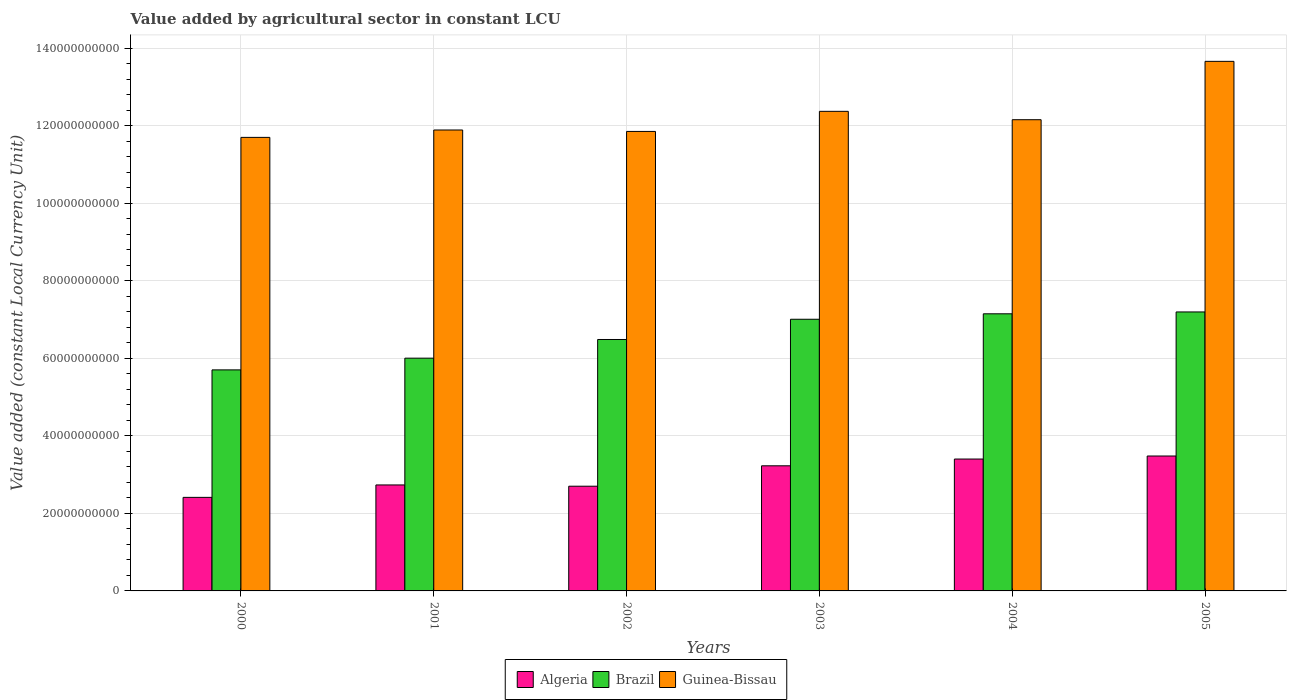How many different coloured bars are there?
Your answer should be compact. 3. How many groups of bars are there?
Keep it short and to the point. 6. How many bars are there on the 1st tick from the left?
Offer a terse response. 3. How many bars are there on the 5th tick from the right?
Provide a succinct answer. 3. What is the label of the 2nd group of bars from the left?
Give a very brief answer. 2001. What is the value added by agricultural sector in Algeria in 2004?
Offer a very short reply. 3.40e+1. Across all years, what is the maximum value added by agricultural sector in Algeria?
Give a very brief answer. 3.48e+1. Across all years, what is the minimum value added by agricultural sector in Brazil?
Provide a succinct answer. 5.70e+1. In which year was the value added by agricultural sector in Brazil maximum?
Your answer should be compact. 2005. In which year was the value added by agricultural sector in Algeria minimum?
Your answer should be compact. 2000. What is the total value added by agricultural sector in Guinea-Bissau in the graph?
Offer a very short reply. 7.36e+11. What is the difference between the value added by agricultural sector in Guinea-Bissau in 2003 and that in 2005?
Provide a succinct answer. -1.29e+1. What is the difference between the value added by agricultural sector in Brazil in 2000 and the value added by agricultural sector in Guinea-Bissau in 2005?
Offer a terse response. -7.96e+1. What is the average value added by agricultural sector in Guinea-Bissau per year?
Offer a very short reply. 1.23e+11. In the year 2002, what is the difference between the value added by agricultural sector in Guinea-Bissau and value added by agricultural sector in Brazil?
Your response must be concise. 5.37e+1. What is the ratio of the value added by agricultural sector in Algeria in 2000 to that in 2003?
Your answer should be compact. 0.75. Is the value added by agricultural sector in Guinea-Bissau in 2001 less than that in 2004?
Your answer should be compact. Yes. What is the difference between the highest and the second highest value added by agricultural sector in Guinea-Bissau?
Your response must be concise. 1.29e+1. What is the difference between the highest and the lowest value added by agricultural sector in Algeria?
Offer a very short reply. 1.07e+1. What does the 1st bar from the left in 2004 represents?
Give a very brief answer. Algeria. What does the 1st bar from the right in 2000 represents?
Ensure brevity in your answer.  Guinea-Bissau. How many bars are there?
Offer a very short reply. 18. Are all the bars in the graph horizontal?
Make the answer very short. No. How many years are there in the graph?
Make the answer very short. 6. Are the values on the major ticks of Y-axis written in scientific E-notation?
Offer a very short reply. No. Does the graph contain any zero values?
Ensure brevity in your answer.  No. How many legend labels are there?
Your response must be concise. 3. How are the legend labels stacked?
Offer a terse response. Horizontal. What is the title of the graph?
Keep it short and to the point. Value added by agricultural sector in constant LCU. What is the label or title of the X-axis?
Give a very brief answer. Years. What is the label or title of the Y-axis?
Your answer should be compact. Value added (constant Local Currency Unit). What is the Value added (constant Local Currency Unit) of Algeria in 2000?
Your answer should be very brief. 2.41e+1. What is the Value added (constant Local Currency Unit) in Brazil in 2000?
Your answer should be compact. 5.70e+1. What is the Value added (constant Local Currency Unit) of Guinea-Bissau in 2000?
Ensure brevity in your answer.  1.17e+11. What is the Value added (constant Local Currency Unit) in Algeria in 2001?
Give a very brief answer. 2.73e+1. What is the Value added (constant Local Currency Unit) in Brazil in 2001?
Ensure brevity in your answer.  6.00e+1. What is the Value added (constant Local Currency Unit) in Guinea-Bissau in 2001?
Your answer should be compact. 1.19e+11. What is the Value added (constant Local Currency Unit) in Algeria in 2002?
Provide a succinct answer. 2.70e+1. What is the Value added (constant Local Currency Unit) of Brazil in 2002?
Keep it short and to the point. 6.49e+1. What is the Value added (constant Local Currency Unit) in Guinea-Bissau in 2002?
Provide a short and direct response. 1.19e+11. What is the Value added (constant Local Currency Unit) of Algeria in 2003?
Your answer should be compact. 3.23e+1. What is the Value added (constant Local Currency Unit) in Brazil in 2003?
Your answer should be compact. 7.01e+1. What is the Value added (constant Local Currency Unit) in Guinea-Bissau in 2003?
Give a very brief answer. 1.24e+11. What is the Value added (constant Local Currency Unit) of Algeria in 2004?
Keep it short and to the point. 3.40e+1. What is the Value added (constant Local Currency Unit) of Brazil in 2004?
Make the answer very short. 7.15e+1. What is the Value added (constant Local Currency Unit) in Guinea-Bissau in 2004?
Provide a short and direct response. 1.22e+11. What is the Value added (constant Local Currency Unit) in Algeria in 2005?
Keep it short and to the point. 3.48e+1. What is the Value added (constant Local Currency Unit) in Brazil in 2005?
Your answer should be very brief. 7.20e+1. What is the Value added (constant Local Currency Unit) of Guinea-Bissau in 2005?
Provide a short and direct response. 1.37e+11. Across all years, what is the maximum Value added (constant Local Currency Unit) in Algeria?
Give a very brief answer. 3.48e+1. Across all years, what is the maximum Value added (constant Local Currency Unit) in Brazil?
Keep it short and to the point. 7.20e+1. Across all years, what is the maximum Value added (constant Local Currency Unit) in Guinea-Bissau?
Provide a short and direct response. 1.37e+11. Across all years, what is the minimum Value added (constant Local Currency Unit) of Algeria?
Offer a very short reply. 2.41e+1. Across all years, what is the minimum Value added (constant Local Currency Unit) of Brazil?
Offer a very short reply. 5.70e+1. Across all years, what is the minimum Value added (constant Local Currency Unit) in Guinea-Bissau?
Make the answer very short. 1.17e+11. What is the total Value added (constant Local Currency Unit) of Algeria in the graph?
Keep it short and to the point. 1.80e+11. What is the total Value added (constant Local Currency Unit) in Brazil in the graph?
Your answer should be compact. 3.95e+11. What is the total Value added (constant Local Currency Unit) of Guinea-Bissau in the graph?
Your response must be concise. 7.36e+11. What is the difference between the Value added (constant Local Currency Unit) of Algeria in 2000 and that in 2001?
Make the answer very short. -3.20e+09. What is the difference between the Value added (constant Local Currency Unit) in Brazil in 2000 and that in 2001?
Ensure brevity in your answer.  -3.02e+09. What is the difference between the Value added (constant Local Currency Unit) of Guinea-Bissau in 2000 and that in 2001?
Offer a very short reply. -1.91e+09. What is the difference between the Value added (constant Local Currency Unit) of Algeria in 2000 and that in 2002?
Keep it short and to the point. -2.88e+09. What is the difference between the Value added (constant Local Currency Unit) of Brazil in 2000 and that in 2002?
Your answer should be compact. -7.84e+09. What is the difference between the Value added (constant Local Currency Unit) of Guinea-Bissau in 2000 and that in 2002?
Make the answer very short. -1.53e+09. What is the difference between the Value added (constant Local Currency Unit) in Algeria in 2000 and that in 2003?
Your answer should be compact. -8.14e+09. What is the difference between the Value added (constant Local Currency Unit) in Brazil in 2000 and that in 2003?
Your answer should be compact. -1.31e+1. What is the difference between the Value added (constant Local Currency Unit) in Guinea-Bissau in 2000 and that in 2003?
Your answer should be compact. -6.72e+09. What is the difference between the Value added (constant Local Currency Unit) in Algeria in 2000 and that in 2004?
Offer a very short reply. -9.88e+09. What is the difference between the Value added (constant Local Currency Unit) in Brazil in 2000 and that in 2004?
Offer a terse response. -1.45e+1. What is the difference between the Value added (constant Local Currency Unit) in Guinea-Bissau in 2000 and that in 2004?
Your answer should be very brief. -4.56e+09. What is the difference between the Value added (constant Local Currency Unit) of Algeria in 2000 and that in 2005?
Your response must be concise. -1.07e+1. What is the difference between the Value added (constant Local Currency Unit) in Brazil in 2000 and that in 2005?
Keep it short and to the point. -1.49e+1. What is the difference between the Value added (constant Local Currency Unit) in Guinea-Bissau in 2000 and that in 2005?
Provide a short and direct response. -1.96e+1. What is the difference between the Value added (constant Local Currency Unit) in Algeria in 2001 and that in 2002?
Your answer should be compact. 3.28e+08. What is the difference between the Value added (constant Local Currency Unit) of Brazil in 2001 and that in 2002?
Offer a terse response. -4.82e+09. What is the difference between the Value added (constant Local Currency Unit) in Guinea-Bissau in 2001 and that in 2002?
Your answer should be very brief. 3.72e+08. What is the difference between the Value added (constant Local Currency Unit) in Algeria in 2001 and that in 2003?
Make the answer very short. -4.94e+09. What is the difference between the Value added (constant Local Currency Unit) in Brazil in 2001 and that in 2003?
Ensure brevity in your answer.  -1.00e+1. What is the difference between the Value added (constant Local Currency Unit) in Guinea-Bissau in 2001 and that in 2003?
Your answer should be compact. -4.81e+09. What is the difference between the Value added (constant Local Currency Unit) of Algeria in 2001 and that in 2004?
Offer a very short reply. -6.68e+09. What is the difference between the Value added (constant Local Currency Unit) of Brazil in 2001 and that in 2004?
Offer a terse response. -1.14e+1. What is the difference between the Value added (constant Local Currency Unit) of Guinea-Bissau in 2001 and that in 2004?
Ensure brevity in your answer.  -2.65e+09. What is the difference between the Value added (constant Local Currency Unit) of Algeria in 2001 and that in 2005?
Make the answer very short. -7.46e+09. What is the difference between the Value added (constant Local Currency Unit) of Brazil in 2001 and that in 2005?
Your response must be concise. -1.19e+1. What is the difference between the Value added (constant Local Currency Unit) of Guinea-Bissau in 2001 and that in 2005?
Your answer should be very brief. -1.77e+1. What is the difference between the Value added (constant Local Currency Unit) of Algeria in 2002 and that in 2003?
Provide a short and direct response. -5.27e+09. What is the difference between the Value added (constant Local Currency Unit) in Brazil in 2002 and that in 2003?
Your response must be concise. -5.22e+09. What is the difference between the Value added (constant Local Currency Unit) in Guinea-Bissau in 2002 and that in 2003?
Your answer should be very brief. -5.18e+09. What is the difference between the Value added (constant Local Currency Unit) of Algeria in 2002 and that in 2004?
Your response must be concise. -7.01e+09. What is the difference between the Value added (constant Local Currency Unit) in Brazil in 2002 and that in 2004?
Keep it short and to the point. -6.63e+09. What is the difference between the Value added (constant Local Currency Unit) in Guinea-Bissau in 2002 and that in 2004?
Keep it short and to the point. -3.02e+09. What is the difference between the Value added (constant Local Currency Unit) in Algeria in 2002 and that in 2005?
Make the answer very short. -7.79e+09. What is the difference between the Value added (constant Local Currency Unit) in Brazil in 2002 and that in 2005?
Give a very brief answer. -7.11e+09. What is the difference between the Value added (constant Local Currency Unit) of Guinea-Bissau in 2002 and that in 2005?
Provide a succinct answer. -1.81e+1. What is the difference between the Value added (constant Local Currency Unit) in Algeria in 2003 and that in 2004?
Your answer should be compact. -1.74e+09. What is the difference between the Value added (constant Local Currency Unit) of Brazil in 2003 and that in 2004?
Make the answer very short. -1.41e+09. What is the difference between the Value added (constant Local Currency Unit) in Guinea-Bissau in 2003 and that in 2004?
Your answer should be very brief. 2.16e+09. What is the difference between the Value added (constant Local Currency Unit) in Algeria in 2003 and that in 2005?
Ensure brevity in your answer.  -2.53e+09. What is the difference between the Value added (constant Local Currency Unit) of Brazil in 2003 and that in 2005?
Offer a terse response. -1.88e+09. What is the difference between the Value added (constant Local Currency Unit) in Guinea-Bissau in 2003 and that in 2005?
Offer a very short reply. -1.29e+1. What is the difference between the Value added (constant Local Currency Unit) in Algeria in 2004 and that in 2005?
Offer a very short reply. -7.82e+08. What is the difference between the Value added (constant Local Currency Unit) in Brazil in 2004 and that in 2005?
Keep it short and to the point. -4.78e+08. What is the difference between the Value added (constant Local Currency Unit) of Guinea-Bissau in 2004 and that in 2005?
Offer a very short reply. -1.51e+1. What is the difference between the Value added (constant Local Currency Unit) of Algeria in 2000 and the Value added (constant Local Currency Unit) of Brazil in 2001?
Ensure brevity in your answer.  -3.59e+1. What is the difference between the Value added (constant Local Currency Unit) of Algeria in 2000 and the Value added (constant Local Currency Unit) of Guinea-Bissau in 2001?
Keep it short and to the point. -9.48e+1. What is the difference between the Value added (constant Local Currency Unit) in Brazil in 2000 and the Value added (constant Local Currency Unit) in Guinea-Bissau in 2001?
Provide a short and direct response. -6.19e+1. What is the difference between the Value added (constant Local Currency Unit) of Algeria in 2000 and the Value added (constant Local Currency Unit) of Brazil in 2002?
Provide a short and direct response. -4.07e+1. What is the difference between the Value added (constant Local Currency Unit) in Algeria in 2000 and the Value added (constant Local Currency Unit) in Guinea-Bissau in 2002?
Make the answer very short. -9.44e+1. What is the difference between the Value added (constant Local Currency Unit) of Brazil in 2000 and the Value added (constant Local Currency Unit) of Guinea-Bissau in 2002?
Provide a short and direct response. -6.15e+1. What is the difference between the Value added (constant Local Currency Unit) of Algeria in 2000 and the Value added (constant Local Currency Unit) of Brazil in 2003?
Offer a very short reply. -4.59e+1. What is the difference between the Value added (constant Local Currency Unit) in Algeria in 2000 and the Value added (constant Local Currency Unit) in Guinea-Bissau in 2003?
Your response must be concise. -9.96e+1. What is the difference between the Value added (constant Local Currency Unit) of Brazil in 2000 and the Value added (constant Local Currency Unit) of Guinea-Bissau in 2003?
Your response must be concise. -6.67e+1. What is the difference between the Value added (constant Local Currency Unit) in Algeria in 2000 and the Value added (constant Local Currency Unit) in Brazil in 2004?
Offer a very short reply. -4.73e+1. What is the difference between the Value added (constant Local Currency Unit) of Algeria in 2000 and the Value added (constant Local Currency Unit) of Guinea-Bissau in 2004?
Your answer should be compact. -9.74e+1. What is the difference between the Value added (constant Local Currency Unit) of Brazil in 2000 and the Value added (constant Local Currency Unit) of Guinea-Bissau in 2004?
Give a very brief answer. -6.45e+1. What is the difference between the Value added (constant Local Currency Unit) of Algeria in 2000 and the Value added (constant Local Currency Unit) of Brazil in 2005?
Your answer should be compact. -4.78e+1. What is the difference between the Value added (constant Local Currency Unit) in Algeria in 2000 and the Value added (constant Local Currency Unit) in Guinea-Bissau in 2005?
Your answer should be compact. -1.12e+11. What is the difference between the Value added (constant Local Currency Unit) in Brazil in 2000 and the Value added (constant Local Currency Unit) in Guinea-Bissau in 2005?
Provide a succinct answer. -7.96e+1. What is the difference between the Value added (constant Local Currency Unit) in Algeria in 2001 and the Value added (constant Local Currency Unit) in Brazil in 2002?
Offer a terse response. -3.75e+1. What is the difference between the Value added (constant Local Currency Unit) in Algeria in 2001 and the Value added (constant Local Currency Unit) in Guinea-Bissau in 2002?
Your answer should be very brief. -9.12e+1. What is the difference between the Value added (constant Local Currency Unit) of Brazil in 2001 and the Value added (constant Local Currency Unit) of Guinea-Bissau in 2002?
Provide a short and direct response. -5.85e+1. What is the difference between the Value added (constant Local Currency Unit) in Algeria in 2001 and the Value added (constant Local Currency Unit) in Brazil in 2003?
Offer a terse response. -4.27e+1. What is the difference between the Value added (constant Local Currency Unit) of Algeria in 2001 and the Value added (constant Local Currency Unit) of Guinea-Bissau in 2003?
Give a very brief answer. -9.64e+1. What is the difference between the Value added (constant Local Currency Unit) in Brazil in 2001 and the Value added (constant Local Currency Unit) in Guinea-Bissau in 2003?
Offer a very short reply. -6.37e+1. What is the difference between the Value added (constant Local Currency Unit) in Algeria in 2001 and the Value added (constant Local Currency Unit) in Brazil in 2004?
Provide a succinct answer. -4.41e+1. What is the difference between the Value added (constant Local Currency Unit) in Algeria in 2001 and the Value added (constant Local Currency Unit) in Guinea-Bissau in 2004?
Ensure brevity in your answer.  -9.42e+1. What is the difference between the Value added (constant Local Currency Unit) in Brazil in 2001 and the Value added (constant Local Currency Unit) in Guinea-Bissau in 2004?
Make the answer very short. -6.15e+1. What is the difference between the Value added (constant Local Currency Unit) in Algeria in 2001 and the Value added (constant Local Currency Unit) in Brazil in 2005?
Provide a succinct answer. -4.46e+1. What is the difference between the Value added (constant Local Currency Unit) in Algeria in 2001 and the Value added (constant Local Currency Unit) in Guinea-Bissau in 2005?
Keep it short and to the point. -1.09e+11. What is the difference between the Value added (constant Local Currency Unit) in Brazil in 2001 and the Value added (constant Local Currency Unit) in Guinea-Bissau in 2005?
Make the answer very short. -7.66e+1. What is the difference between the Value added (constant Local Currency Unit) of Algeria in 2002 and the Value added (constant Local Currency Unit) of Brazil in 2003?
Provide a short and direct response. -4.31e+1. What is the difference between the Value added (constant Local Currency Unit) of Algeria in 2002 and the Value added (constant Local Currency Unit) of Guinea-Bissau in 2003?
Make the answer very short. -9.67e+1. What is the difference between the Value added (constant Local Currency Unit) of Brazil in 2002 and the Value added (constant Local Currency Unit) of Guinea-Bissau in 2003?
Make the answer very short. -5.88e+1. What is the difference between the Value added (constant Local Currency Unit) of Algeria in 2002 and the Value added (constant Local Currency Unit) of Brazil in 2004?
Your answer should be very brief. -4.45e+1. What is the difference between the Value added (constant Local Currency Unit) of Algeria in 2002 and the Value added (constant Local Currency Unit) of Guinea-Bissau in 2004?
Your answer should be very brief. -9.45e+1. What is the difference between the Value added (constant Local Currency Unit) of Brazil in 2002 and the Value added (constant Local Currency Unit) of Guinea-Bissau in 2004?
Your answer should be very brief. -5.67e+1. What is the difference between the Value added (constant Local Currency Unit) of Algeria in 2002 and the Value added (constant Local Currency Unit) of Brazil in 2005?
Offer a very short reply. -4.49e+1. What is the difference between the Value added (constant Local Currency Unit) in Algeria in 2002 and the Value added (constant Local Currency Unit) in Guinea-Bissau in 2005?
Keep it short and to the point. -1.10e+11. What is the difference between the Value added (constant Local Currency Unit) of Brazil in 2002 and the Value added (constant Local Currency Unit) of Guinea-Bissau in 2005?
Your answer should be very brief. -7.17e+1. What is the difference between the Value added (constant Local Currency Unit) in Algeria in 2003 and the Value added (constant Local Currency Unit) in Brazil in 2004?
Make the answer very short. -3.92e+1. What is the difference between the Value added (constant Local Currency Unit) in Algeria in 2003 and the Value added (constant Local Currency Unit) in Guinea-Bissau in 2004?
Make the answer very short. -8.93e+1. What is the difference between the Value added (constant Local Currency Unit) in Brazil in 2003 and the Value added (constant Local Currency Unit) in Guinea-Bissau in 2004?
Offer a very short reply. -5.15e+1. What is the difference between the Value added (constant Local Currency Unit) of Algeria in 2003 and the Value added (constant Local Currency Unit) of Brazil in 2005?
Keep it short and to the point. -3.97e+1. What is the difference between the Value added (constant Local Currency Unit) in Algeria in 2003 and the Value added (constant Local Currency Unit) in Guinea-Bissau in 2005?
Keep it short and to the point. -1.04e+11. What is the difference between the Value added (constant Local Currency Unit) of Brazil in 2003 and the Value added (constant Local Currency Unit) of Guinea-Bissau in 2005?
Offer a terse response. -6.65e+1. What is the difference between the Value added (constant Local Currency Unit) of Algeria in 2004 and the Value added (constant Local Currency Unit) of Brazil in 2005?
Your answer should be very brief. -3.79e+1. What is the difference between the Value added (constant Local Currency Unit) of Algeria in 2004 and the Value added (constant Local Currency Unit) of Guinea-Bissau in 2005?
Provide a short and direct response. -1.03e+11. What is the difference between the Value added (constant Local Currency Unit) of Brazil in 2004 and the Value added (constant Local Currency Unit) of Guinea-Bissau in 2005?
Give a very brief answer. -6.51e+1. What is the average Value added (constant Local Currency Unit) in Algeria per year?
Your answer should be compact. 2.99e+1. What is the average Value added (constant Local Currency Unit) of Brazil per year?
Your answer should be compact. 6.59e+1. What is the average Value added (constant Local Currency Unit) in Guinea-Bissau per year?
Ensure brevity in your answer.  1.23e+11. In the year 2000, what is the difference between the Value added (constant Local Currency Unit) of Algeria and Value added (constant Local Currency Unit) of Brazil?
Your response must be concise. -3.29e+1. In the year 2000, what is the difference between the Value added (constant Local Currency Unit) in Algeria and Value added (constant Local Currency Unit) in Guinea-Bissau?
Provide a succinct answer. -9.29e+1. In the year 2000, what is the difference between the Value added (constant Local Currency Unit) of Brazil and Value added (constant Local Currency Unit) of Guinea-Bissau?
Provide a short and direct response. -6.00e+1. In the year 2001, what is the difference between the Value added (constant Local Currency Unit) in Algeria and Value added (constant Local Currency Unit) in Brazil?
Give a very brief answer. -3.27e+1. In the year 2001, what is the difference between the Value added (constant Local Currency Unit) of Algeria and Value added (constant Local Currency Unit) of Guinea-Bissau?
Your answer should be compact. -9.16e+1. In the year 2001, what is the difference between the Value added (constant Local Currency Unit) of Brazil and Value added (constant Local Currency Unit) of Guinea-Bissau?
Your response must be concise. -5.89e+1. In the year 2002, what is the difference between the Value added (constant Local Currency Unit) of Algeria and Value added (constant Local Currency Unit) of Brazil?
Give a very brief answer. -3.78e+1. In the year 2002, what is the difference between the Value added (constant Local Currency Unit) in Algeria and Value added (constant Local Currency Unit) in Guinea-Bissau?
Ensure brevity in your answer.  -9.15e+1. In the year 2002, what is the difference between the Value added (constant Local Currency Unit) of Brazil and Value added (constant Local Currency Unit) of Guinea-Bissau?
Provide a succinct answer. -5.37e+1. In the year 2003, what is the difference between the Value added (constant Local Currency Unit) in Algeria and Value added (constant Local Currency Unit) in Brazil?
Offer a terse response. -3.78e+1. In the year 2003, what is the difference between the Value added (constant Local Currency Unit) of Algeria and Value added (constant Local Currency Unit) of Guinea-Bissau?
Offer a very short reply. -9.14e+1. In the year 2003, what is the difference between the Value added (constant Local Currency Unit) of Brazil and Value added (constant Local Currency Unit) of Guinea-Bissau?
Your answer should be compact. -5.36e+1. In the year 2004, what is the difference between the Value added (constant Local Currency Unit) in Algeria and Value added (constant Local Currency Unit) in Brazil?
Ensure brevity in your answer.  -3.75e+1. In the year 2004, what is the difference between the Value added (constant Local Currency Unit) of Algeria and Value added (constant Local Currency Unit) of Guinea-Bissau?
Provide a succinct answer. -8.75e+1. In the year 2004, what is the difference between the Value added (constant Local Currency Unit) of Brazil and Value added (constant Local Currency Unit) of Guinea-Bissau?
Your response must be concise. -5.01e+1. In the year 2005, what is the difference between the Value added (constant Local Currency Unit) in Algeria and Value added (constant Local Currency Unit) in Brazil?
Ensure brevity in your answer.  -3.72e+1. In the year 2005, what is the difference between the Value added (constant Local Currency Unit) in Algeria and Value added (constant Local Currency Unit) in Guinea-Bissau?
Make the answer very short. -1.02e+11. In the year 2005, what is the difference between the Value added (constant Local Currency Unit) of Brazil and Value added (constant Local Currency Unit) of Guinea-Bissau?
Offer a very short reply. -6.46e+1. What is the ratio of the Value added (constant Local Currency Unit) of Algeria in 2000 to that in 2001?
Provide a short and direct response. 0.88. What is the ratio of the Value added (constant Local Currency Unit) in Brazil in 2000 to that in 2001?
Your answer should be compact. 0.95. What is the ratio of the Value added (constant Local Currency Unit) of Guinea-Bissau in 2000 to that in 2001?
Provide a succinct answer. 0.98. What is the ratio of the Value added (constant Local Currency Unit) of Algeria in 2000 to that in 2002?
Provide a succinct answer. 0.89. What is the ratio of the Value added (constant Local Currency Unit) in Brazil in 2000 to that in 2002?
Keep it short and to the point. 0.88. What is the ratio of the Value added (constant Local Currency Unit) of Guinea-Bissau in 2000 to that in 2002?
Your answer should be very brief. 0.99. What is the ratio of the Value added (constant Local Currency Unit) of Algeria in 2000 to that in 2003?
Keep it short and to the point. 0.75. What is the ratio of the Value added (constant Local Currency Unit) in Brazil in 2000 to that in 2003?
Your answer should be compact. 0.81. What is the ratio of the Value added (constant Local Currency Unit) of Guinea-Bissau in 2000 to that in 2003?
Your response must be concise. 0.95. What is the ratio of the Value added (constant Local Currency Unit) of Algeria in 2000 to that in 2004?
Make the answer very short. 0.71. What is the ratio of the Value added (constant Local Currency Unit) in Brazil in 2000 to that in 2004?
Provide a succinct answer. 0.8. What is the ratio of the Value added (constant Local Currency Unit) in Guinea-Bissau in 2000 to that in 2004?
Ensure brevity in your answer.  0.96. What is the ratio of the Value added (constant Local Currency Unit) of Algeria in 2000 to that in 2005?
Give a very brief answer. 0.69. What is the ratio of the Value added (constant Local Currency Unit) of Brazil in 2000 to that in 2005?
Keep it short and to the point. 0.79. What is the ratio of the Value added (constant Local Currency Unit) of Guinea-Bissau in 2000 to that in 2005?
Offer a very short reply. 0.86. What is the ratio of the Value added (constant Local Currency Unit) in Algeria in 2001 to that in 2002?
Provide a succinct answer. 1.01. What is the ratio of the Value added (constant Local Currency Unit) in Brazil in 2001 to that in 2002?
Offer a very short reply. 0.93. What is the ratio of the Value added (constant Local Currency Unit) in Algeria in 2001 to that in 2003?
Give a very brief answer. 0.85. What is the ratio of the Value added (constant Local Currency Unit) of Brazil in 2001 to that in 2003?
Give a very brief answer. 0.86. What is the ratio of the Value added (constant Local Currency Unit) in Guinea-Bissau in 2001 to that in 2003?
Keep it short and to the point. 0.96. What is the ratio of the Value added (constant Local Currency Unit) of Algeria in 2001 to that in 2004?
Your answer should be compact. 0.8. What is the ratio of the Value added (constant Local Currency Unit) of Brazil in 2001 to that in 2004?
Keep it short and to the point. 0.84. What is the ratio of the Value added (constant Local Currency Unit) of Guinea-Bissau in 2001 to that in 2004?
Make the answer very short. 0.98. What is the ratio of the Value added (constant Local Currency Unit) in Algeria in 2001 to that in 2005?
Your answer should be compact. 0.79. What is the ratio of the Value added (constant Local Currency Unit) in Brazil in 2001 to that in 2005?
Ensure brevity in your answer.  0.83. What is the ratio of the Value added (constant Local Currency Unit) in Guinea-Bissau in 2001 to that in 2005?
Offer a terse response. 0.87. What is the ratio of the Value added (constant Local Currency Unit) of Algeria in 2002 to that in 2003?
Keep it short and to the point. 0.84. What is the ratio of the Value added (constant Local Currency Unit) of Brazil in 2002 to that in 2003?
Ensure brevity in your answer.  0.93. What is the ratio of the Value added (constant Local Currency Unit) in Guinea-Bissau in 2002 to that in 2003?
Offer a terse response. 0.96. What is the ratio of the Value added (constant Local Currency Unit) of Algeria in 2002 to that in 2004?
Your response must be concise. 0.79. What is the ratio of the Value added (constant Local Currency Unit) of Brazil in 2002 to that in 2004?
Ensure brevity in your answer.  0.91. What is the ratio of the Value added (constant Local Currency Unit) of Guinea-Bissau in 2002 to that in 2004?
Your answer should be compact. 0.98. What is the ratio of the Value added (constant Local Currency Unit) of Algeria in 2002 to that in 2005?
Make the answer very short. 0.78. What is the ratio of the Value added (constant Local Currency Unit) in Brazil in 2002 to that in 2005?
Provide a short and direct response. 0.9. What is the ratio of the Value added (constant Local Currency Unit) in Guinea-Bissau in 2002 to that in 2005?
Make the answer very short. 0.87. What is the ratio of the Value added (constant Local Currency Unit) of Algeria in 2003 to that in 2004?
Keep it short and to the point. 0.95. What is the ratio of the Value added (constant Local Currency Unit) of Brazil in 2003 to that in 2004?
Provide a succinct answer. 0.98. What is the ratio of the Value added (constant Local Currency Unit) in Guinea-Bissau in 2003 to that in 2004?
Provide a short and direct response. 1.02. What is the ratio of the Value added (constant Local Currency Unit) of Algeria in 2003 to that in 2005?
Ensure brevity in your answer.  0.93. What is the ratio of the Value added (constant Local Currency Unit) of Brazil in 2003 to that in 2005?
Your answer should be very brief. 0.97. What is the ratio of the Value added (constant Local Currency Unit) in Guinea-Bissau in 2003 to that in 2005?
Ensure brevity in your answer.  0.91. What is the ratio of the Value added (constant Local Currency Unit) of Algeria in 2004 to that in 2005?
Give a very brief answer. 0.98. What is the ratio of the Value added (constant Local Currency Unit) in Guinea-Bissau in 2004 to that in 2005?
Make the answer very short. 0.89. What is the difference between the highest and the second highest Value added (constant Local Currency Unit) in Algeria?
Your answer should be compact. 7.82e+08. What is the difference between the highest and the second highest Value added (constant Local Currency Unit) in Brazil?
Offer a terse response. 4.78e+08. What is the difference between the highest and the second highest Value added (constant Local Currency Unit) of Guinea-Bissau?
Keep it short and to the point. 1.29e+1. What is the difference between the highest and the lowest Value added (constant Local Currency Unit) of Algeria?
Your response must be concise. 1.07e+1. What is the difference between the highest and the lowest Value added (constant Local Currency Unit) in Brazil?
Provide a succinct answer. 1.49e+1. What is the difference between the highest and the lowest Value added (constant Local Currency Unit) in Guinea-Bissau?
Give a very brief answer. 1.96e+1. 